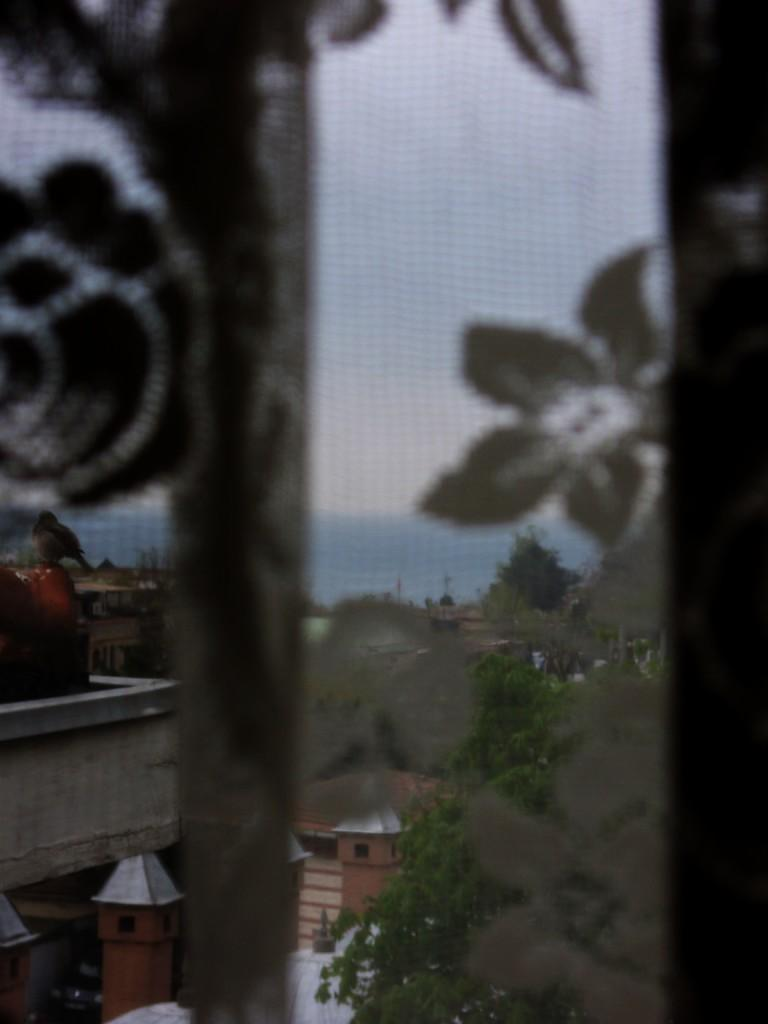What type of material is present in the image? There is cloth in the image. What type of natural environment can be seen in the image? There are trees in the image. What type of man-made structures are visible in the image? There are buildings in the image. What type of landscape feature is visible in the image? There is water visible in the image. What part of the natural environment is visible in the image? The sky is visible in the image. What type of pest can be seen crawling on the cloth in the image? There is no pest visible on the cloth in the image. What type of flowers are growing near the trees in the image? There is no mention of flowers in the image; only trees are mentioned. 